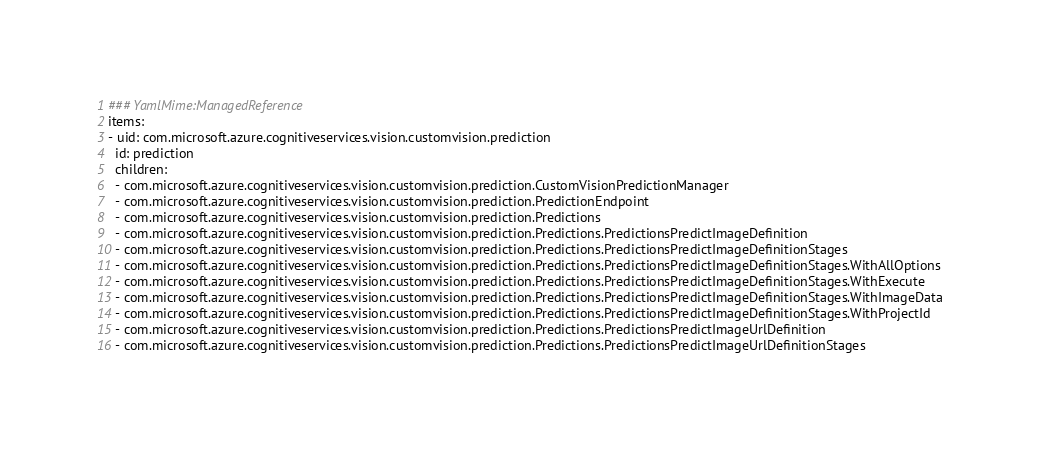<code> <loc_0><loc_0><loc_500><loc_500><_YAML_>### YamlMime:ManagedReference
items:
- uid: com.microsoft.azure.cognitiveservices.vision.customvision.prediction
  id: prediction
  children:
  - com.microsoft.azure.cognitiveservices.vision.customvision.prediction.CustomVisionPredictionManager
  - com.microsoft.azure.cognitiveservices.vision.customvision.prediction.PredictionEndpoint
  - com.microsoft.azure.cognitiveservices.vision.customvision.prediction.Predictions
  - com.microsoft.azure.cognitiveservices.vision.customvision.prediction.Predictions.PredictionsPredictImageDefinition
  - com.microsoft.azure.cognitiveservices.vision.customvision.prediction.Predictions.PredictionsPredictImageDefinitionStages
  - com.microsoft.azure.cognitiveservices.vision.customvision.prediction.Predictions.PredictionsPredictImageDefinitionStages.WithAllOptions
  - com.microsoft.azure.cognitiveservices.vision.customvision.prediction.Predictions.PredictionsPredictImageDefinitionStages.WithExecute
  - com.microsoft.azure.cognitiveservices.vision.customvision.prediction.Predictions.PredictionsPredictImageDefinitionStages.WithImageData
  - com.microsoft.azure.cognitiveservices.vision.customvision.prediction.Predictions.PredictionsPredictImageDefinitionStages.WithProjectId
  - com.microsoft.azure.cognitiveservices.vision.customvision.prediction.Predictions.PredictionsPredictImageUrlDefinition
  - com.microsoft.azure.cognitiveservices.vision.customvision.prediction.Predictions.PredictionsPredictImageUrlDefinitionStages</code> 